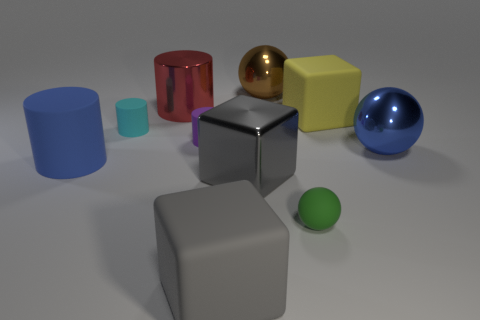Is there a big gray thing made of the same material as the small green sphere?
Offer a very short reply. Yes. What material is the big cylinder that is behind the large matte cube that is behind the small green rubber ball?
Offer a terse response. Metal. Are there the same number of big cubes right of the green object and large blue metallic objects to the left of the large gray rubber block?
Your response must be concise. No. Is the red thing the same shape as the cyan matte thing?
Make the answer very short. Yes. There is a block that is both in front of the large blue ball and behind the gray matte cube; what is it made of?
Make the answer very short. Metal. How many other matte objects are the same shape as the brown thing?
Offer a terse response. 1. There is a gray object that is on the left side of the large shiny thing that is in front of the blue thing to the right of the large gray rubber object; what is its size?
Provide a succinct answer. Large. Is the number of metal spheres on the left side of the tiny purple matte thing greater than the number of large gray matte blocks?
Offer a very short reply. No. Are there any tiny green objects?
Provide a succinct answer. Yes. What number of gray blocks are the same size as the cyan matte cylinder?
Give a very brief answer. 0. 